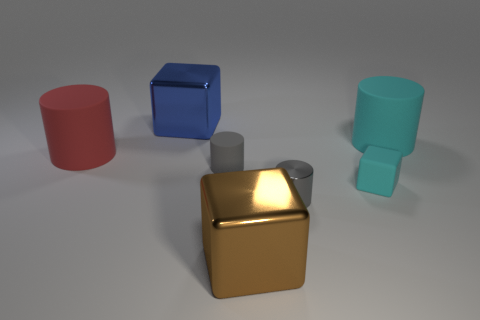Add 2 tiny blocks. How many objects exist? 9 Subtract all blocks. How many objects are left? 4 Add 2 cyan matte cubes. How many cyan matte cubes are left? 3 Add 2 tiny green spheres. How many tiny green spheres exist? 2 Subtract 0 gray balls. How many objects are left? 7 Subtract all big red rubber things. Subtract all large blue blocks. How many objects are left? 5 